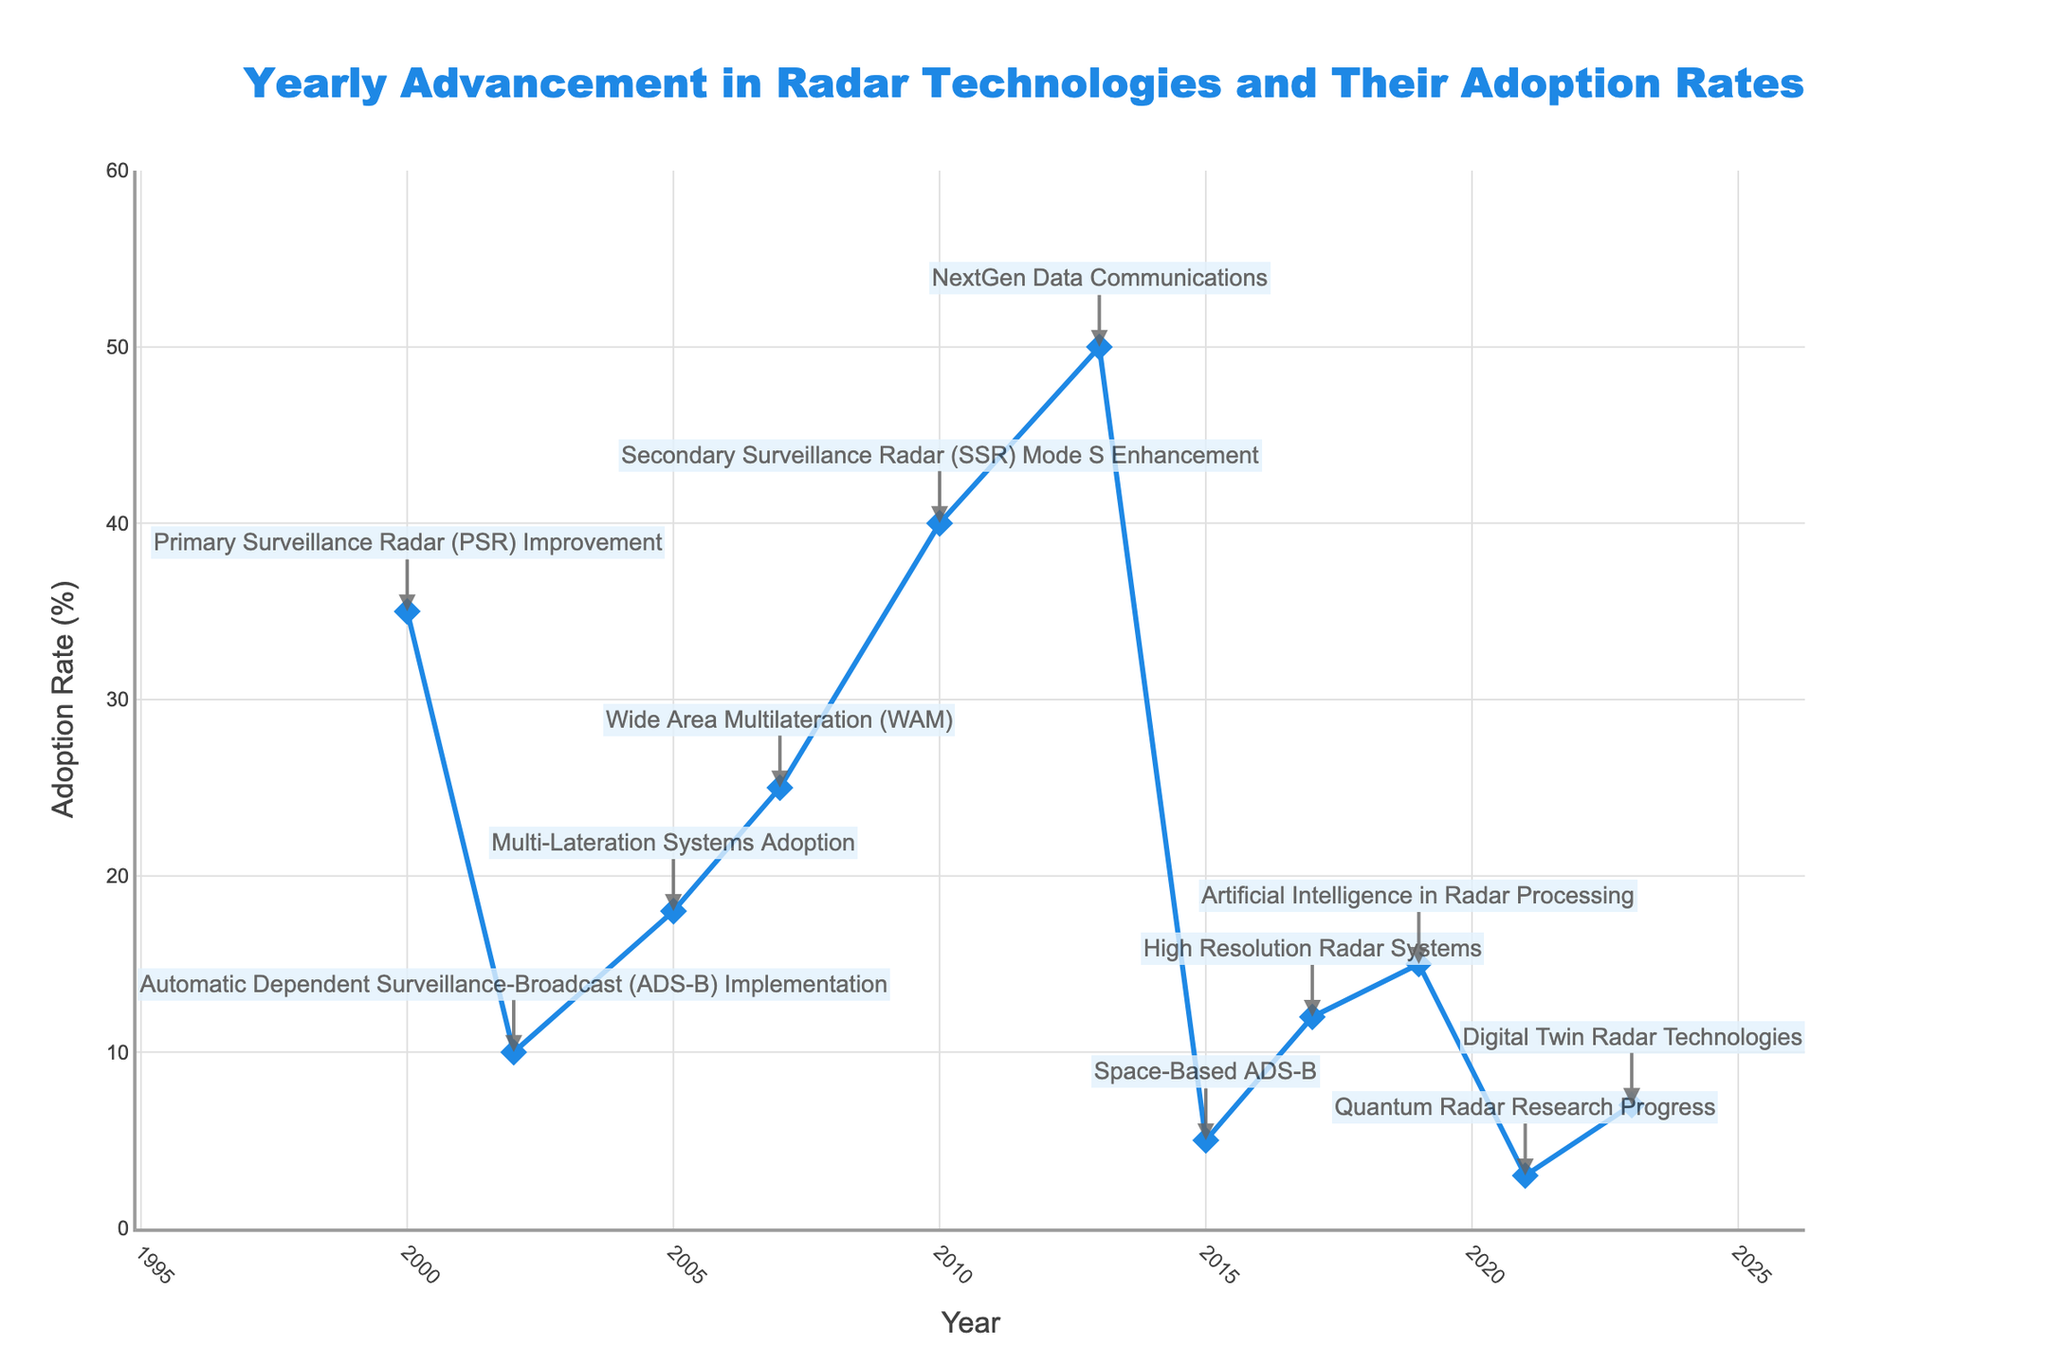What is the title of the plot? The title is typically situated at the top of the plot. In this case, it reads "Yearly Advancement in Radar Technologies and Their Adoption Rates".
Answer: Yearly Advancement in Radar Technologies and Their Adoption Rates In which year was the adoption rate percentage the highest? By examining the y-axis for the highest value, we see that it occurs in 2013, corresponding to the adoption of "NextGen Data Communications".
Answer: 2013 Which technological advancement had the lowest adoption rate? Looking at the y-axis for the lowest value, it occurs in 2021 with an adoption rate of 3%, corresponding to "Quantum Radar Research Progress".
Answer: Quantum Radar Research Progress How many technological advancements are labeled on the plot? Count the number of technological advancement labels annotated on the plot. There are 11 labels in total.
Answer: 11 What is the trend in adoption rates from 2000 to 2023? Observing the line plot as time progresses, we see fluctuations in the adoption rates, with some peaks and dips, rather than a consistent increase or decrease.
Answer: Fluctuating trend What is the difference in adoption rate between the year 2000 and 2013? The adoption rate in 2000 was 35%, and in 2013 it was 50%. The difference is calculated as 50% - 35% = 15%.
Answer: 15% Which year saw a sharp rise in adoption percentage compared to its previous recorded year? Comparing the differences between consecutive years, the sharpest rise is from 2007 (25%) to 2010 (40%), an increase of 15%.
Answer: 2010 Which technological advancements have an adoption rate between 10% and 20%? Identify the advancements corresponding to this range: "Multi-Lateration Systems Adoption" (18%), "High Resolution Radar Systems" (12%), and "Artificial Intelligence in Radar Processing" (15%).
Answer: Multi-Lateration Systems Adoption, High Resolution Radar Systems, Artificial Intelligence in Radar Processing What is the average adoption rate percentage over the period 2000 to 2023? Summing the adoption rates (35 + 10 + 18 + 25 + 40 + 50 + 5 + 12 + 15 + 3 + 7) = 220, and dividing by the number of data points (11), we get an average of 220 / 11 = 20%.
Answer: 20% What is indicated by the annotations in the plot? The annotations provide the specific radar technology advancements corresponding to each year and their respective adoption rates, giving context to the plotted data points.
Answer: Radar technology advancements 